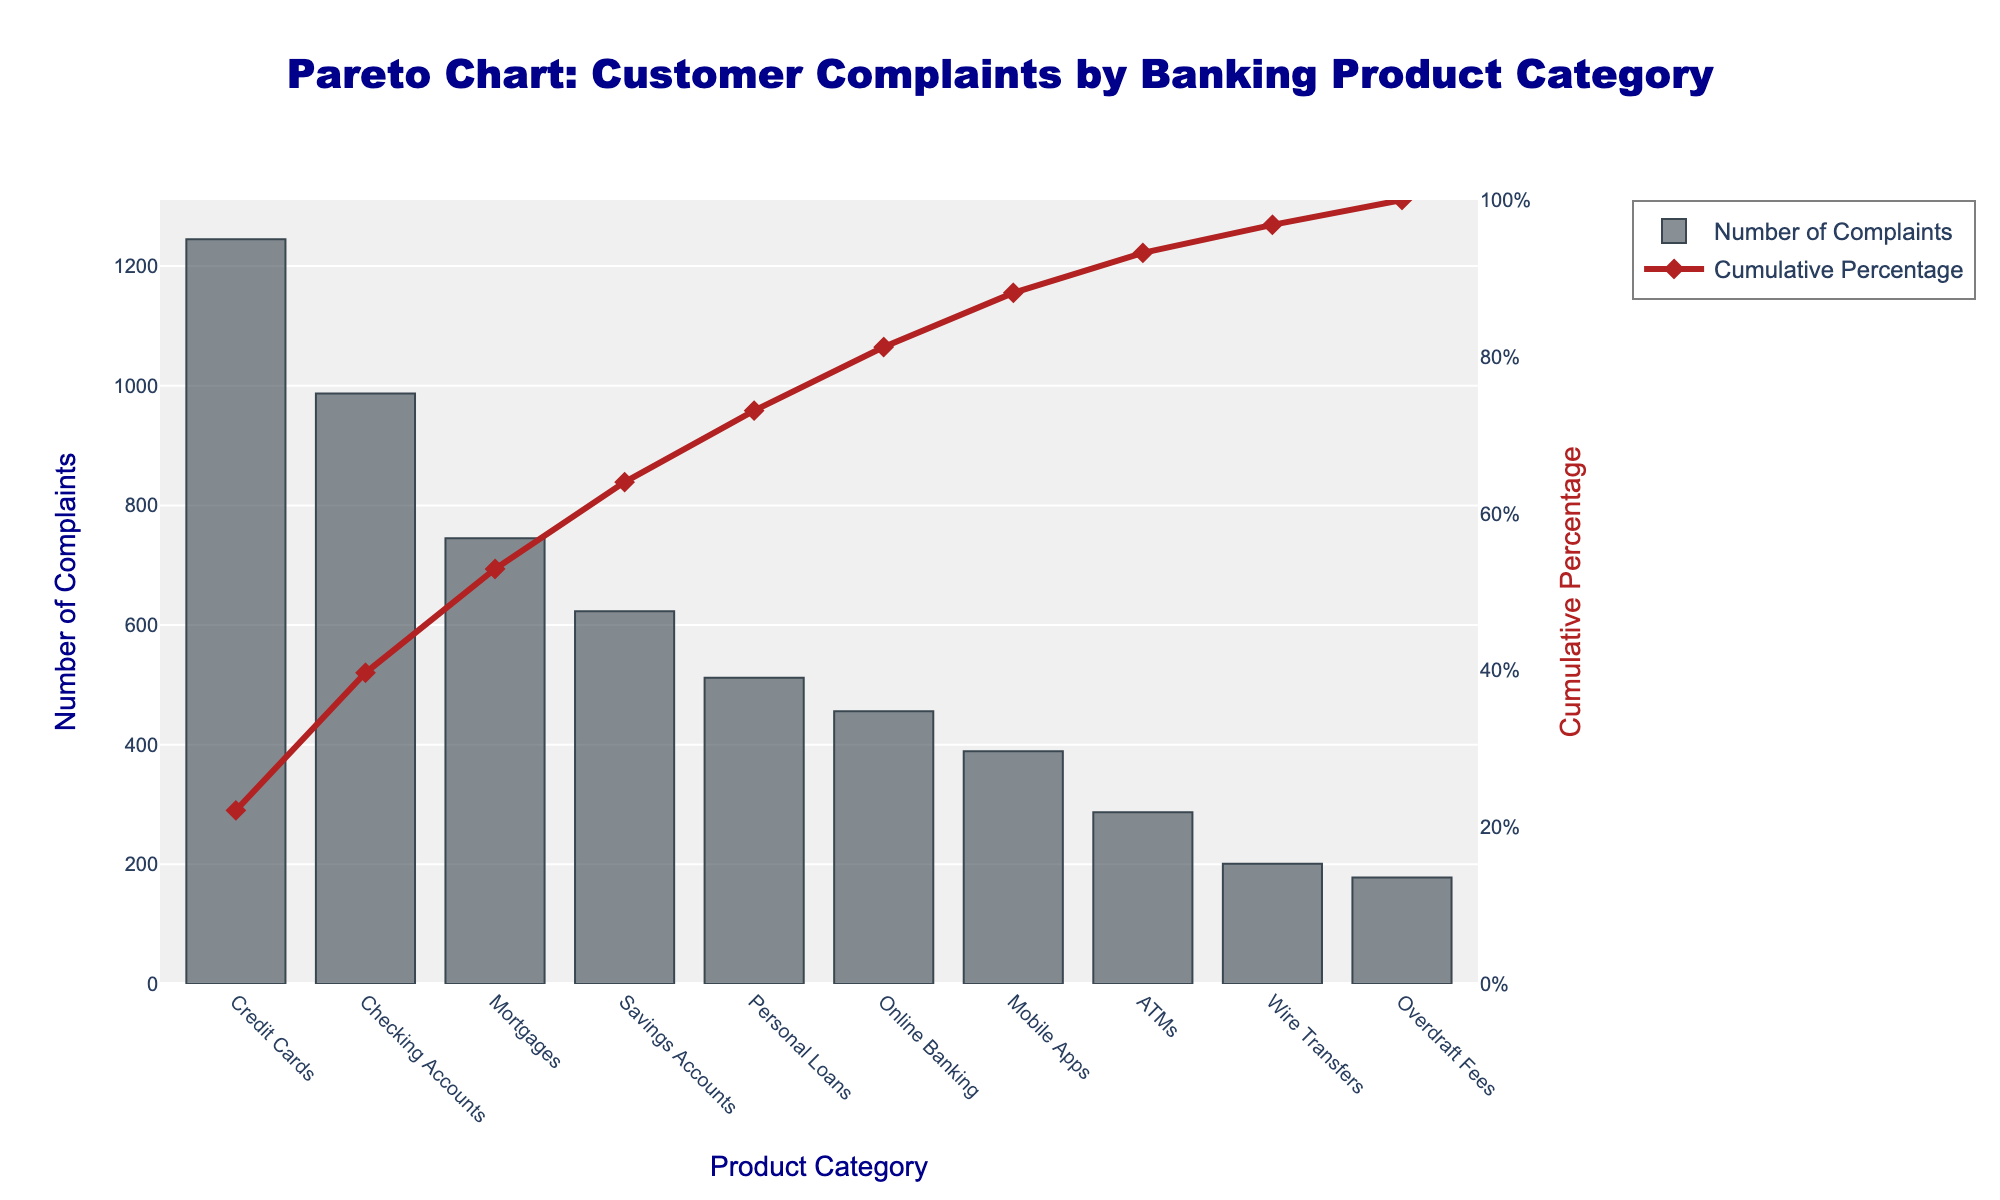What is the title of the figure? The title is placed at the top center of the figure, and it reads: "Pareto Chart: Customer Complaints by Banking Product Category".
Answer: Pareto Chart: Customer Complaints by Banking Product Category Which product category has the highest number of complaints? The product category with the highest number of complaints is indicated by the tallest bar in the bar chart. The tallest bar represents "Credit Cards" with 1,245 complaints.
Answer: Credit Cards What is the cumulative percentage of complaints for Mortgages? To find the cumulative percentage for Mortgages, look at the point on the red cumulative percentage line that corresponds to Mortgages on the x-axis. This point indicates approximately 66%.
Answer: 66% How many more complaints are there for Checking Accounts compared to Savings Accounts? To find the difference, look at the heights of the bars for Checking Accounts and Savings Accounts. Checking Accounts have 987 complaints and Savings Accounts have 623. Subtract 623 from 987 to get the difference. 987 - 623 = 364
Answer: 364 What percentage of total complaints do Credit Cards and Checking Accounts together represent? Add the number of complaints for Credit Cards (1,245) and Checking Accounts (987) to get the total for these categories: 1,245 + 987 = 2,232. Calculate the total number of complaints for all categories by summing the values. The total is 5,623. The percentage is (2,232 / 5,623) * 100 ≈ 39.7%.
Answer: 39.7% At what cumulative percentage does the Online Banking category fall? Identify the point on the red cumulative percentage line that aligns with Online Banking on the x-axis. This point indicates approximately 80%.
Answer: 80% Which product category has the lowest number of complaints and how many complaints does it have? The product category with the lowest number of complaints is represented by the shortest bar on the bar chart. The shortest bar represents "Overdraft Fees" with 178 complaints.
Answer: Overdraft Fees, 178 Is the cumulative percentage above 50% after the top two categories? After the top two categories (Credit Cards and Checking Accounts), the cumulative percentage can be seen above the x-axis labels. The cumulative percentage after the second category is above 50%, closer to 70%.
Answer: Yes How much smaller is the number of complaints for Personal Loans compared to Credit Cards? Subtract the number of complaints for Personal Loans (512) from the number of complaints for Credit Cards (1,245): 1,245 - 512 = 733.
Answer: 733 What can you infer about the concentration of complaints across different product categories from the Pareto chart? The Pareto chart shows that a few categories (mainly Credit Cards and Checking Accounts) accumulate a significant percentage of total complaints, while the majority of remaining categories have much fewer complaints. This is indicated by the steep rise in the cumulative percentage line when moving from the largest to the smallest categories.
Answer: Concentrated among few categories 